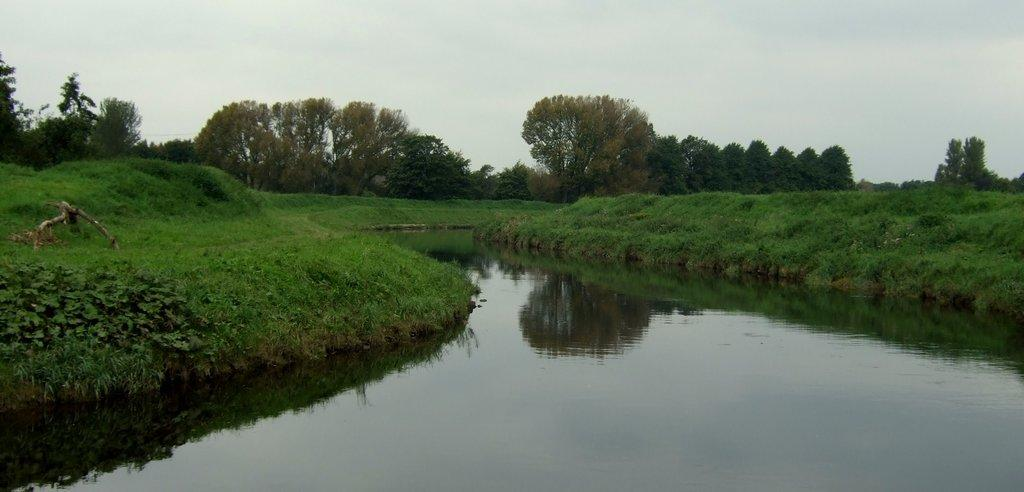What is the main subject in the center of the image? There is water in the center of the image. What type of vegetation is present on both sides of the water? There is grass on both sides of the water. What can be seen in the background of the image? There are trees and the sky visible in the background of the image. Where is the magic wand being used in the image? There is no magic wand present in the image. What type of steel structure can be seen in the image? There is no steel structure present in the image. 